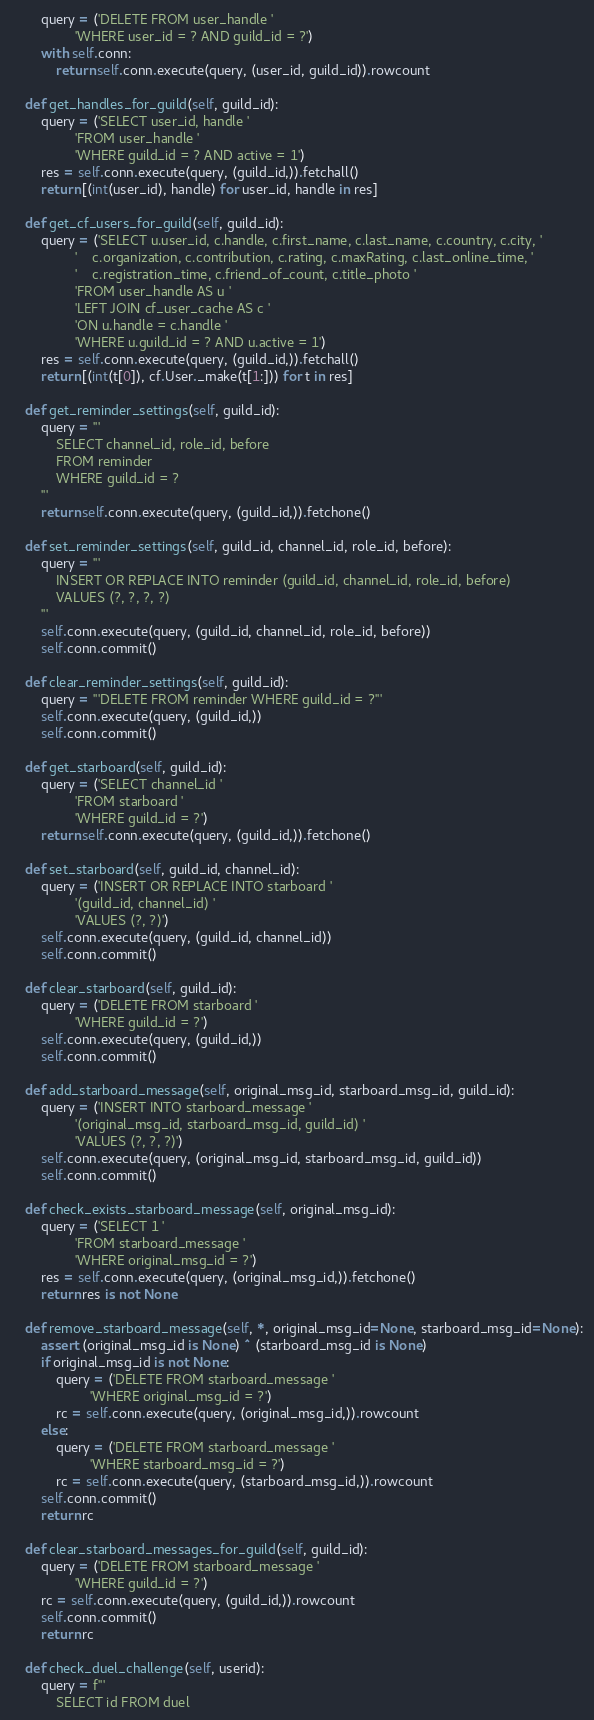Convert code to text. <code><loc_0><loc_0><loc_500><loc_500><_Python_>        query = ('DELETE FROM user_handle '
                 'WHERE user_id = ? AND guild_id = ?')
        with self.conn:
            return self.conn.execute(query, (user_id, guild_id)).rowcount

    def get_handles_for_guild(self, guild_id):
        query = ('SELECT user_id, handle '
                 'FROM user_handle '
                 'WHERE guild_id = ? AND active = 1')
        res = self.conn.execute(query, (guild_id,)).fetchall()
        return [(int(user_id), handle) for user_id, handle in res]

    def get_cf_users_for_guild(self, guild_id):
        query = ('SELECT u.user_id, c.handle, c.first_name, c.last_name, c.country, c.city, '
                 '    c.organization, c.contribution, c.rating, c.maxRating, c.last_online_time, '
                 '    c.registration_time, c.friend_of_count, c.title_photo '
                 'FROM user_handle AS u '
                 'LEFT JOIN cf_user_cache AS c '
                 'ON u.handle = c.handle '
                 'WHERE u.guild_id = ? AND u.active = 1')
        res = self.conn.execute(query, (guild_id,)).fetchall()
        return [(int(t[0]), cf.User._make(t[1:])) for t in res]

    def get_reminder_settings(self, guild_id):
        query = '''
            SELECT channel_id, role_id, before
            FROM reminder
            WHERE guild_id = ?
        '''
        return self.conn.execute(query, (guild_id,)).fetchone()

    def set_reminder_settings(self, guild_id, channel_id, role_id, before):
        query = '''
            INSERT OR REPLACE INTO reminder (guild_id, channel_id, role_id, before)
            VALUES (?, ?, ?, ?)
        '''
        self.conn.execute(query, (guild_id, channel_id, role_id, before))
        self.conn.commit()

    def clear_reminder_settings(self, guild_id):
        query = '''DELETE FROM reminder WHERE guild_id = ?'''
        self.conn.execute(query, (guild_id,))
        self.conn.commit()

    def get_starboard(self, guild_id):
        query = ('SELECT channel_id '
                 'FROM starboard '
                 'WHERE guild_id = ?')
        return self.conn.execute(query, (guild_id,)).fetchone()

    def set_starboard(self, guild_id, channel_id):
        query = ('INSERT OR REPLACE INTO starboard '
                 '(guild_id, channel_id) '
                 'VALUES (?, ?)')
        self.conn.execute(query, (guild_id, channel_id))
        self.conn.commit()

    def clear_starboard(self, guild_id):
        query = ('DELETE FROM starboard '
                 'WHERE guild_id = ?')
        self.conn.execute(query, (guild_id,))
        self.conn.commit()

    def add_starboard_message(self, original_msg_id, starboard_msg_id, guild_id):
        query = ('INSERT INTO starboard_message '
                 '(original_msg_id, starboard_msg_id, guild_id) '
                 'VALUES (?, ?, ?)')
        self.conn.execute(query, (original_msg_id, starboard_msg_id, guild_id))
        self.conn.commit()

    def check_exists_starboard_message(self, original_msg_id):
        query = ('SELECT 1 '
                 'FROM starboard_message '
                 'WHERE original_msg_id = ?')
        res = self.conn.execute(query, (original_msg_id,)).fetchone()
        return res is not None

    def remove_starboard_message(self, *, original_msg_id=None, starboard_msg_id=None):
        assert (original_msg_id is None) ^ (starboard_msg_id is None)
        if original_msg_id is not None:
            query = ('DELETE FROM starboard_message '
                     'WHERE original_msg_id = ?')
            rc = self.conn.execute(query, (original_msg_id,)).rowcount
        else:
            query = ('DELETE FROM starboard_message '
                     'WHERE starboard_msg_id = ?')
            rc = self.conn.execute(query, (starboard_msg_id,)).rowcount
        self.conn.commit()
        return rc

    def clear_starboard_messages_for_guild(self, guild_id):
        query = ('DELETE FROM starboard_message '
                 'WHERE guild_id = ?')
        rc = self.conn.execute(query, (guild_id,)).rowcount
        self.conn.commit()
        return rc

    def check_duel_challenge(self, userid):
        query = f'''
            SELECT id FROM duel</code> 